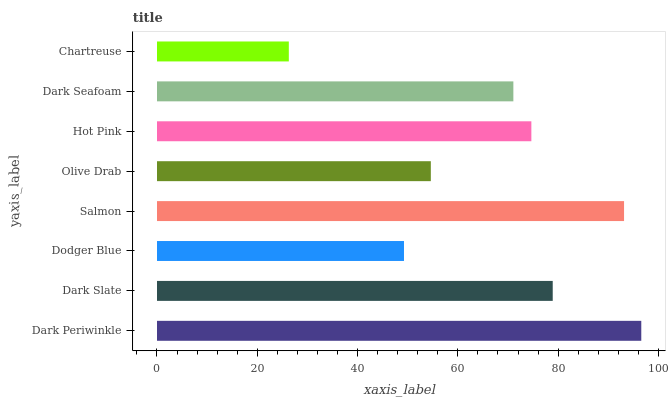Is Chartreuse the minimum?
Answer yes or no. Yes. Is Dark Periwinkle the maximum?
Answer yes or no. Yes. Is Dark Slate the minimum?
Answer yes or no. No. Is Dark Slate the maximum?
Answer yes or no. No. Is Dark Periwinkle greater than Dark Slate?
Answer yes or no. Yes. Is Dark Slate less than Dark Periwinkle?
Answer yes or no. Yes. Is Dark Slate greater than Dark Periwinkle?
Answer yes or no. No. Is Dark Periwinkle less than Dark Slate?
Answer yes or no. No. Is Hot Pink the high median?
Answer yes or no. Yes. Is Dark Seafoam the low median?
Answer yes or no. Yes. Is Dark Periwinkle the high median?
Answer yes or no. No. Is Dark Slate the low median?
Answer yes or no. No. 